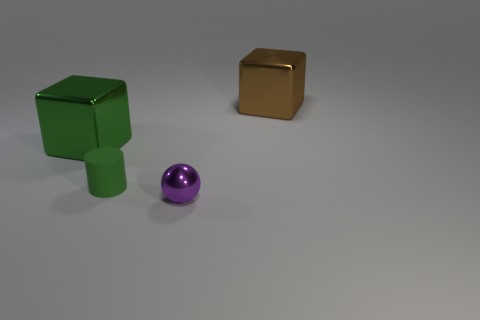Add 3 big purple things. How many objects exist? 7 Subtract 0 cyan cylinders. How many objects are left? 4 Subtract all spheres. How many objects are left? 3 Subtract all blue cylinders. Subtract all cyan cubes. How many cylinders are left? 1 Subtract all big brown cubes. Subtract all small rubber cylinders. How many objects are left? 2 Add 4 tiny spheres. How many tiny spheres are left? 5 Add 1 small green blocks. How many small green blocks exist? 1 